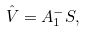<formula> <loc_0><loc_0><loc_500><loc_500>\hat { V } = A _ { 1 } ^ { - } S ,</formula> 